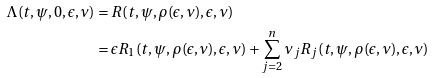<formula> <loc_0><loc_0><loc_500><loc_500>\Lambda ( t , \psi , 0 , \epsilon , \nu ) & = R ( t , \psi , \rho ( \epsilon , \nu ) , \epsilon , \nu ) \\ & = \epsilon R _ { 1 } ( t , \psi , \rho ( \epsilon , \nu ) , \epsilon , \nu ) + \sum _ { j = 2 } ^ { n } \nu _ { j } R _ { j } ( t , \psi , \rho ( \epsilon , \nu ) , \epsilon , \nu )</formula> 